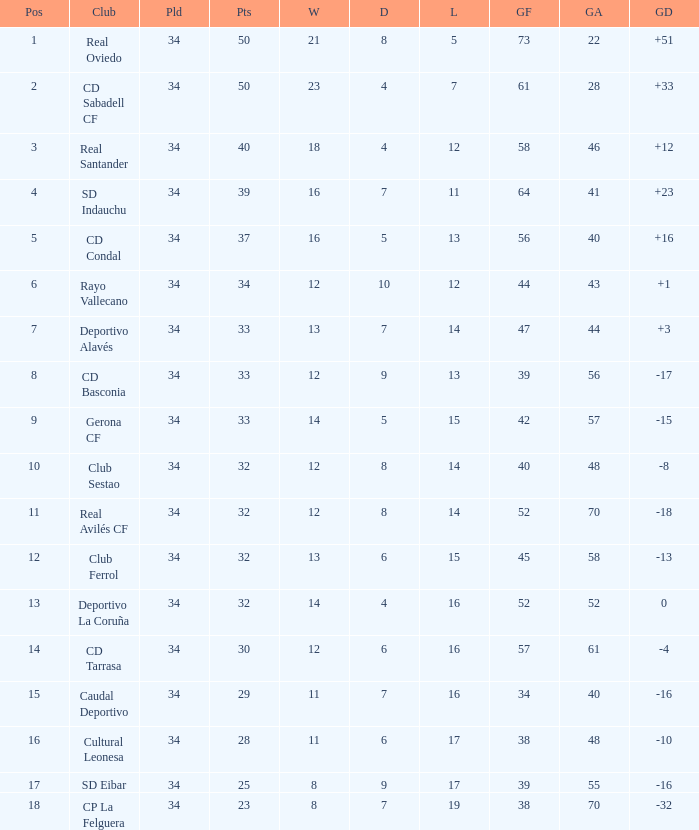Which Played has Draws smaller than 7, and Goals for smaller than 61, and Goals against smaller than 48, and a Position of 5? 34.0. 